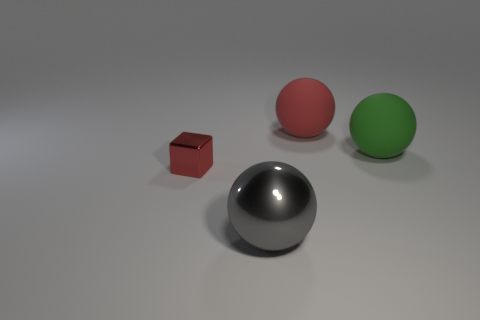Subtract all blocks. How many objects are left? 3 Subtract all large red balls. How many balls are left? 2 Subtract 1 spheres. How many spheres are left? 2 Subtract all cyan cubes. Subtract all green cylinders. How many cubes are left? 1 Subtract all purple blocks. How many gray balls are left? 1 Subtract all blue metal cylinders. Subtract all rubber objects. How many objects are left? 2 Add 1 gray metallic balls. How many gray metallic balls are left? 2 Add 4 blue matte balls. How many blue matte balls exist? 4 Add 3 red balls. How many objects exist? 7 Subtract all green balls. How many balls are left? 2 